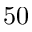<formula> <loc_0><loc_0><loc_500><loc_500>5 0</formula> 